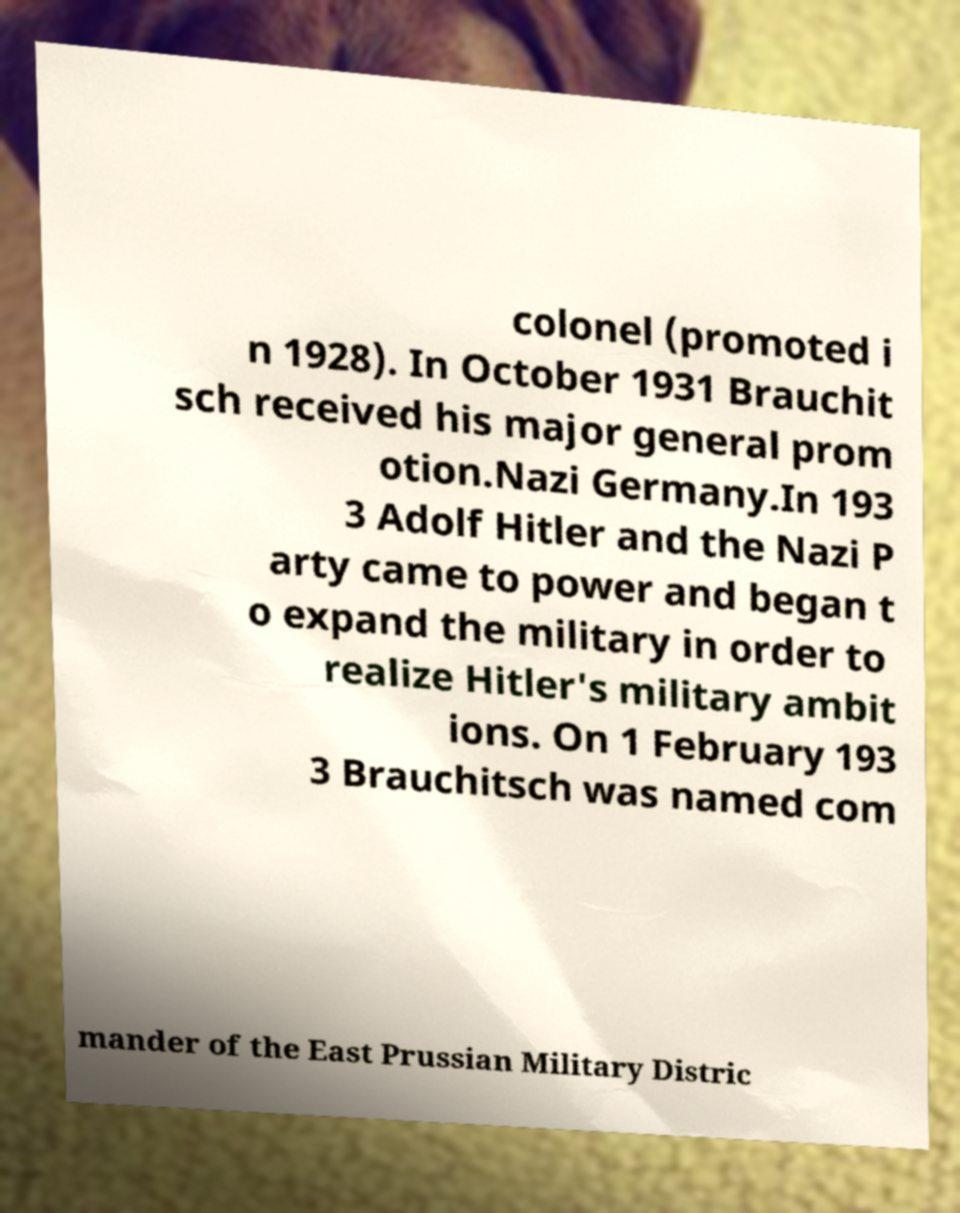Please read and relay the text visible in this image. What does it say? colonel (promoted i n 1928). In October 1931 Brauchit sch received his major general prom otion.Nazi Germany.In 193 3 Adolf Hitler and the Nazi P arty came to power and began t o expand the military in order to realize Hitler's military ambit ions. On 1 February 193 3 Brauchitsch was named com mander of the East Prussian Military Distric 